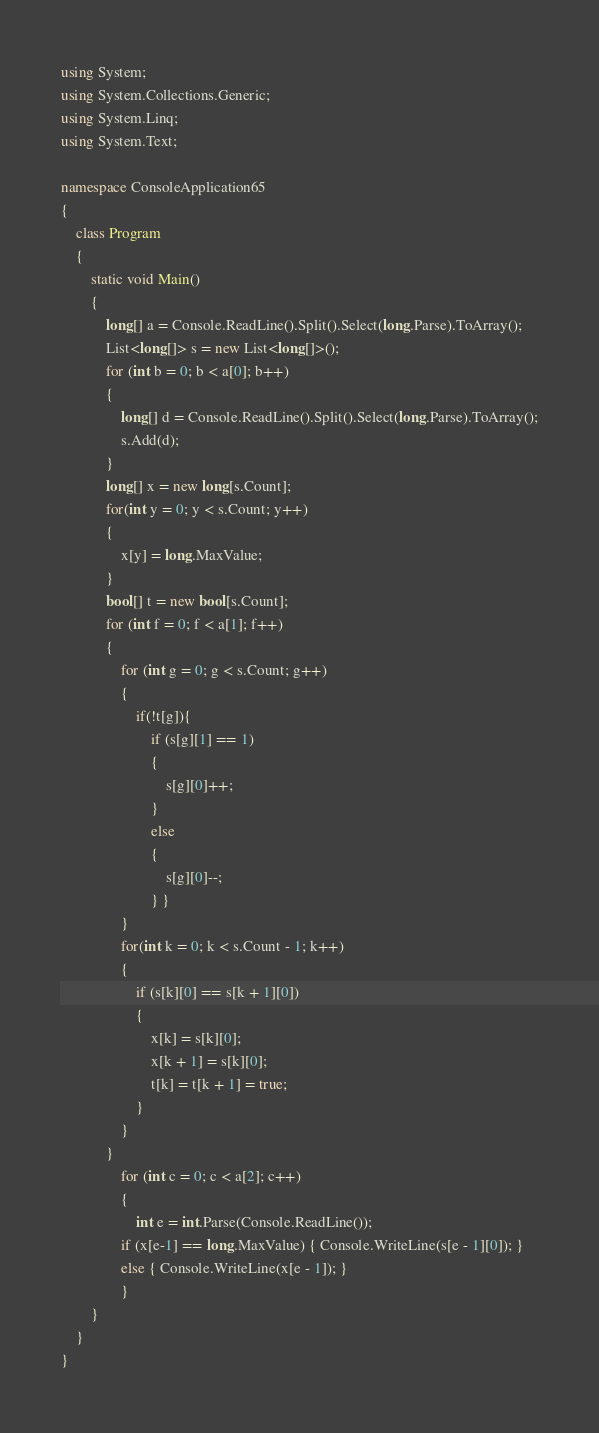<code> <loc_0><loc_0><loc_500><loc_500><_C#_>using System;
using System.Collections.Generic;
using System.Linq;
using System.Text;

namespace ConsoleApplication65
{
    class Program
    {
        static void Main()
        {
            long[] a = Console.ReadLine().Split().Select(long.Parse).ToArray();
            List<long[]> s = new List<long[]>();
            for (int b = 0; b < a[0]; b++)
            {
                long[] d = Console.ReadLine().Split().Select(long.Parse).ToArray();
                s.Add(d);
            }
            long[] x = new long[s.Count];
            for(int y = 0; y < s.Count; y++)
            {
                x[y] = long.MaxValue;
            }
            bool[] t = new bool[s.Count];
            for (int f = 0; f < a[1]; f++)
            {
                for (int g = 0; g < s.Count; g++)
                {
                    if(!t[g]){
                        if (s[g][1] == 1)
                        {
                            s[g][0]++;
                        }
                        else
                        {
                            s[g][0]--;
                        } }
                }
                for(int k = 0; k < s.Count - 1; k++)
                {
                    if (s[k][0] == s[k + 1][0])
                    {
                        x[k] = s[k][0];
                        x[k + 1] = s[k][0];
                        t[k] = t[k + 1] = true;
                    }
                }
            }
                for (int c = 0; c < a[2]; c++)
                {
                    int e = int.Parse(Console.ReadLine());
                if (x[e-1] == long.MaxValue) { Console.WriteLine(s[e - 1][0]); }
                else { Console.WriteLine(x[e - 1]); }
                }           
        }
    }
}</code> 